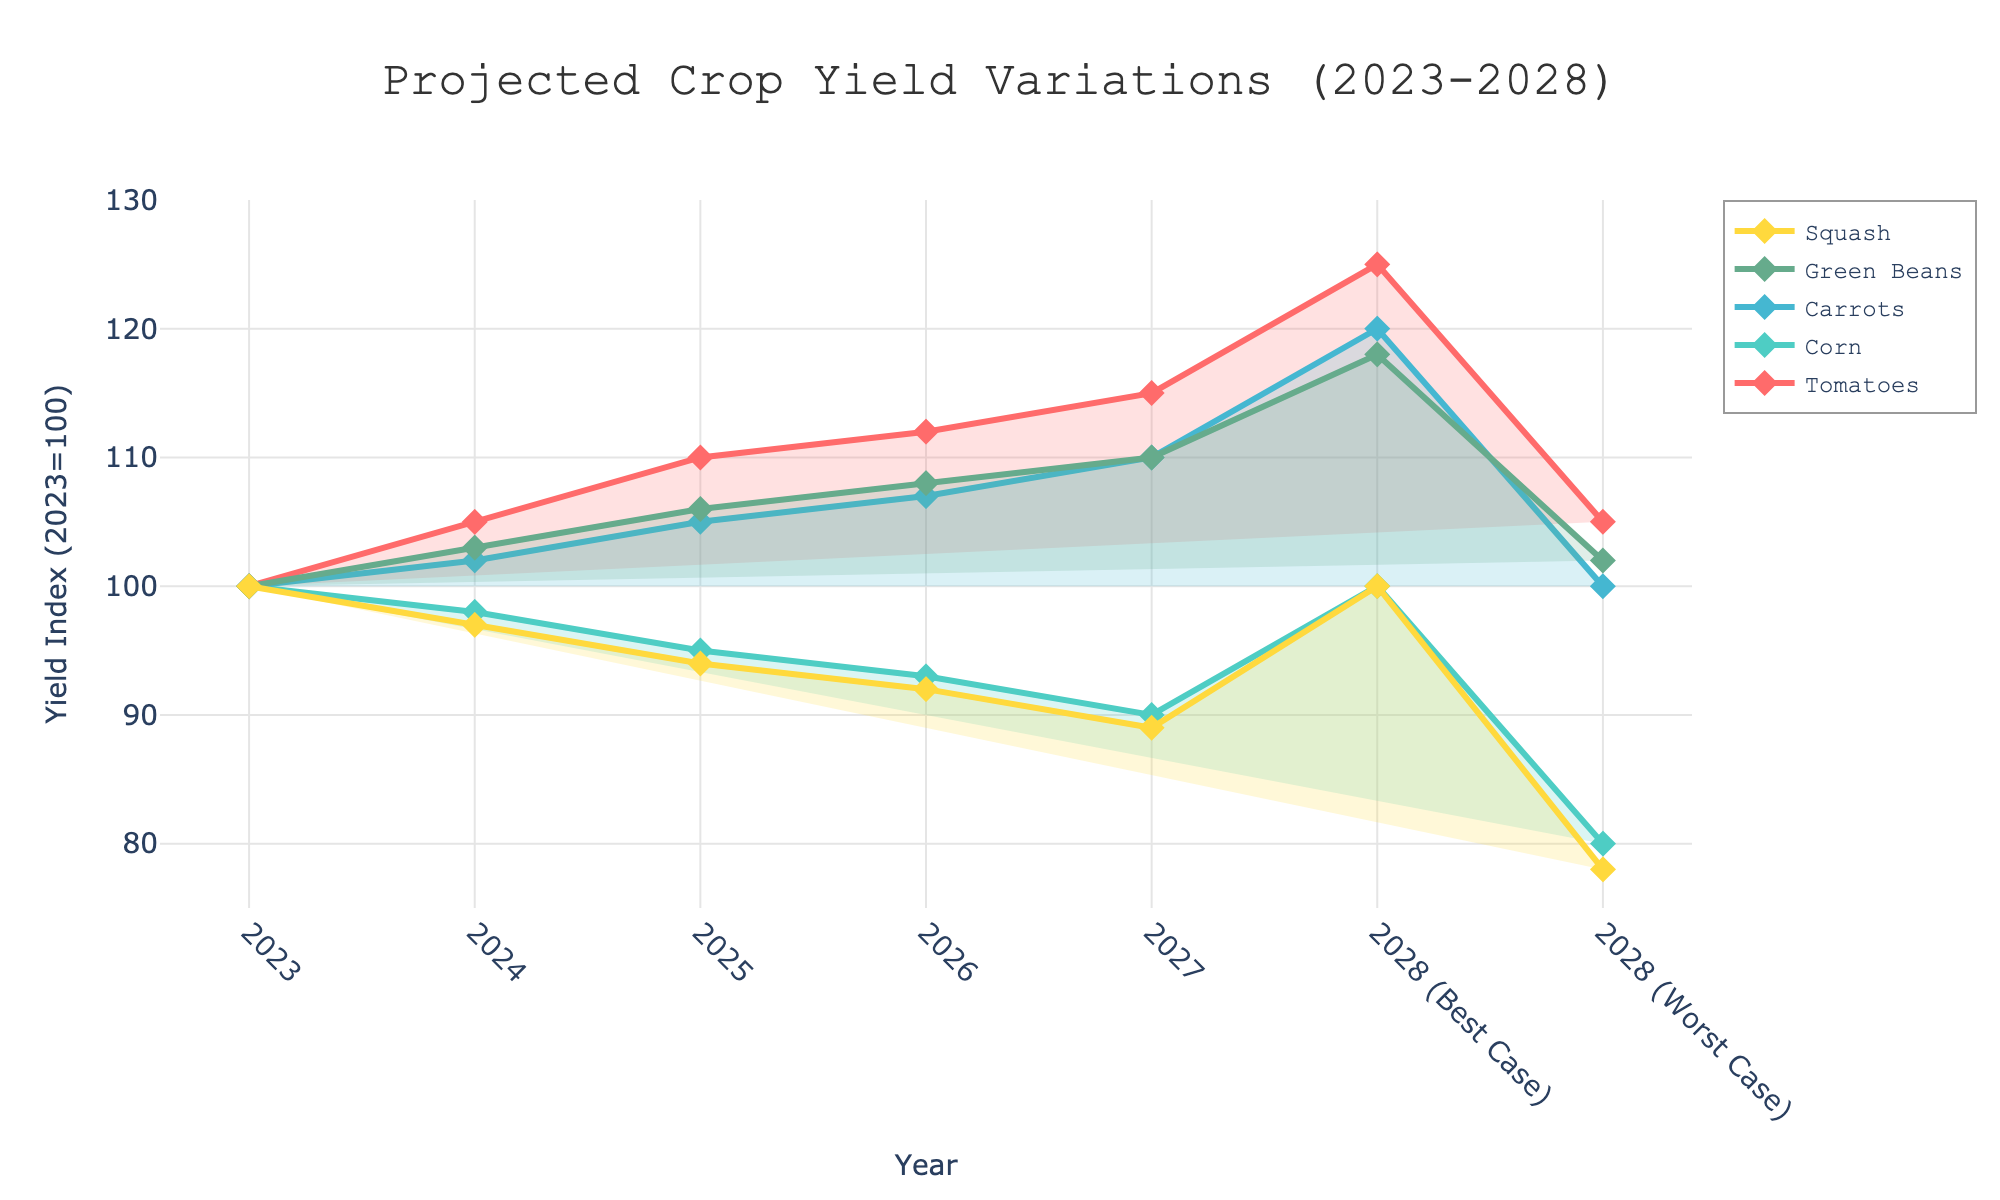What is the title of the figure? The title is the text displayed at the top of the chart, in this case it reads "Projected Crop Yield Variations (2023-2028)".
Answer: Projected Crop Yield Variations (2023-2028) How many different crops are being tracked in the figure? You can count the unique lines on the chart representing distinct crops. There are five lines, each with different colors and labels.
Answer: 5 Which crop is projected to have the highest yield in 2028 under the best-case scenario? To find this, look at the upper bound of the band for each crop in 2028. Among Tomatoes, Corn, Carrots, Green Beans, and Squash, Tomatoes reaches the highest value of 125.
Answer: Tomatoes What is the expected yield index for Corn in 2025? Identify the data point for Corn in the year 2025 on the chart. According to the data provided, the yield index for Corn in 2025 is 95.
Answer: 95 Compared to 2023, is the projected yield for Carrots expected to increase or decrease in 2028 under the worst-case scenario? Locate the yield index for Carrots in 2023 and compare it with the worst-case scenario value in 2028. The yield in 2023 is 100, and the worst-case forecast for 2028 is 100, showing no change.
Answer: No change What's the difference in the yield index of Green Beans between 2024 and 2026? Look at the data points for Green Beans in 2024 (103) and 2026 (108). The difference is calculated as 108 - 103.
Answer: 5 Which crop shows the least amount of variation between the best and worst-case scenarios in 2028? The variation is represented by the size of the band in 2028. For each crop, calculate the difference between the best and worst-case values in 2028. Squash has the smallest variation, with a difference of 22.
Answer: Squash Are Green Beans projected to have continuous growth or any decline over the years 2023 to 2028? Observe the trend line for Green Beans from 2023 to 2028. The data shows a steady increase in yield each year.
Answer: Continuous growth What is the average projected yield index for Tomatoes from 2023 to 2027? Add up the yield indices for Tomatoes from 2023 (100), 2024 (105), 2025 (110), 2026 (112), and 2027 (115), then divide by the number of years: (100 + 105 + 110 + 112 + 115) / 5.
Answer: 108.4 